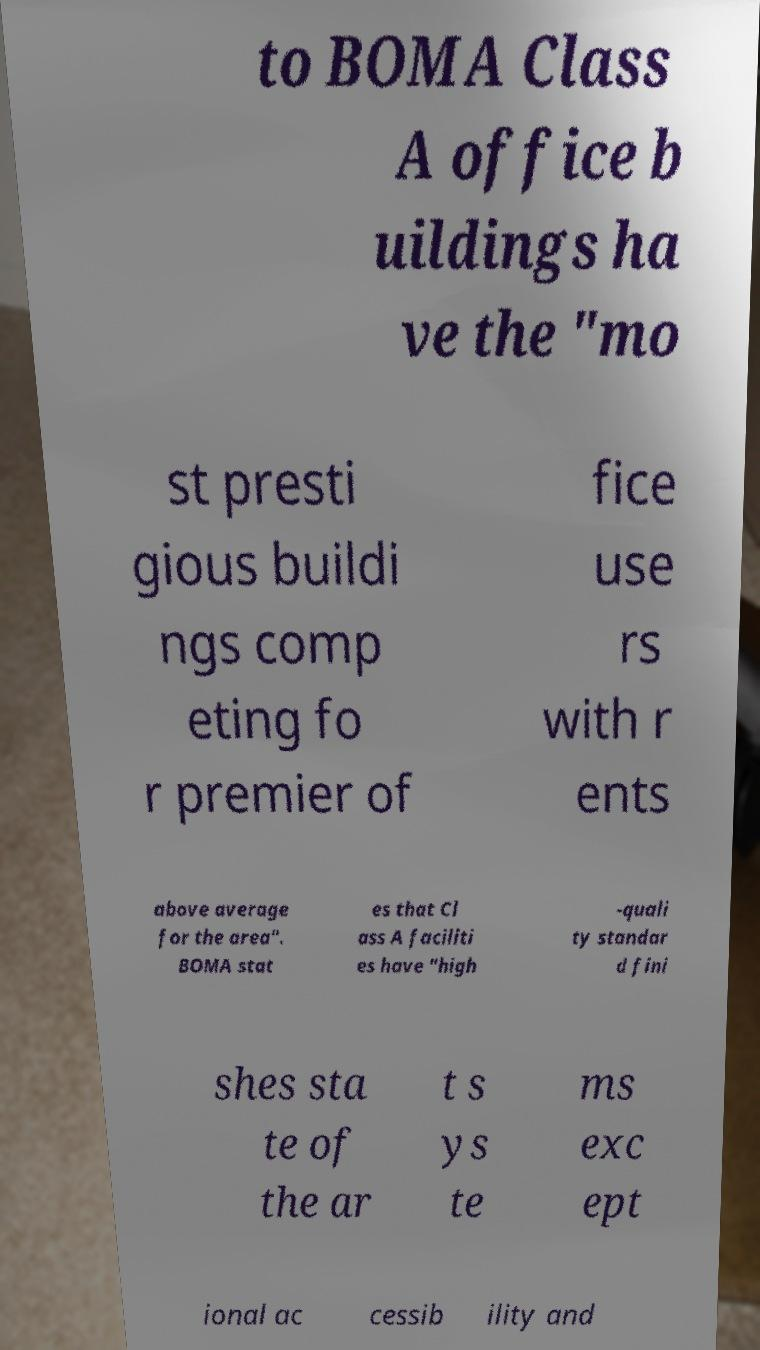I need the written content from this picture converted into text. Can you do that? to BOMA Class A office b uildings ha ve the "mo st presti gious buildi ngs comp eting fo r premier of fice use rs with r ents above average for the area". BOMA stat es that Cl ass A faciliti es have "high -quali ty standar d fini shes sta te of the ar t s ys te ms exc ept ional ac cessib ility and 